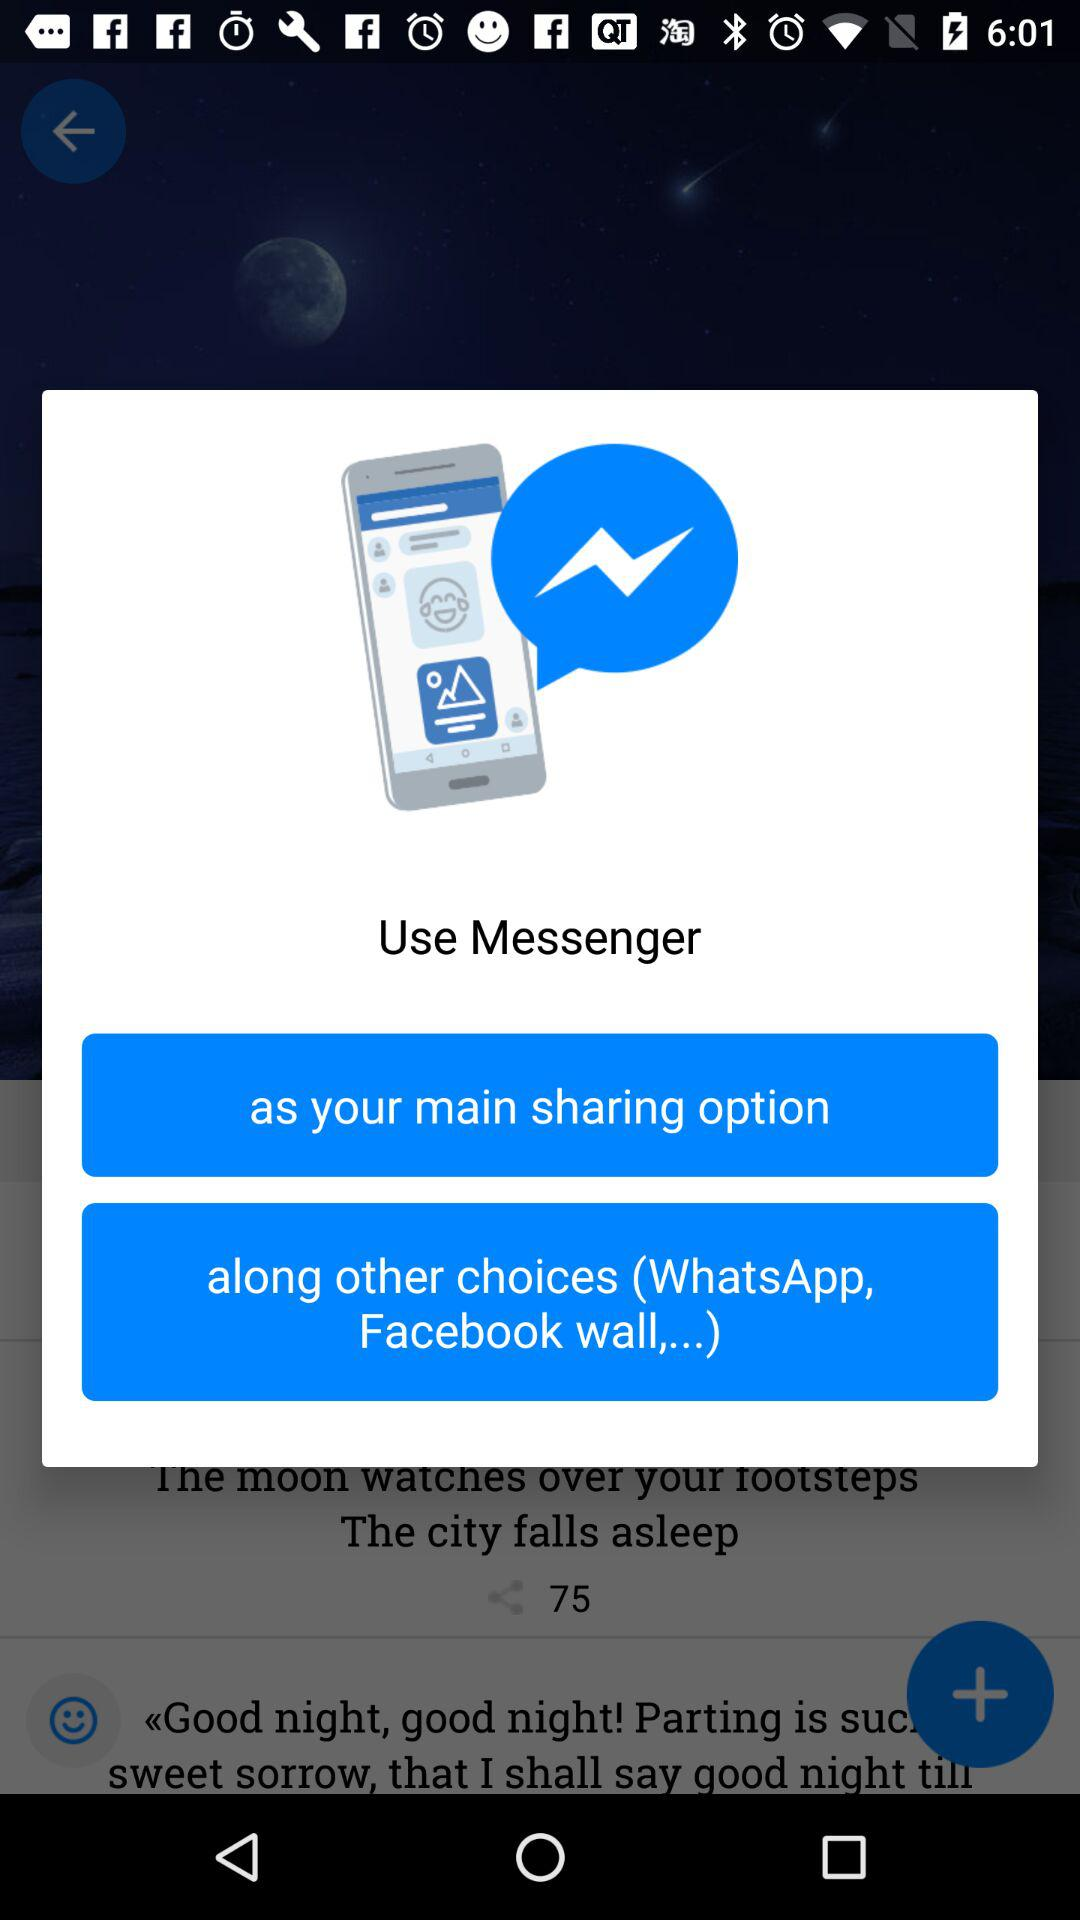What are the names of the applications? The names of the applications are "Messenger", "WhatsApp" and "Facebook wall". 